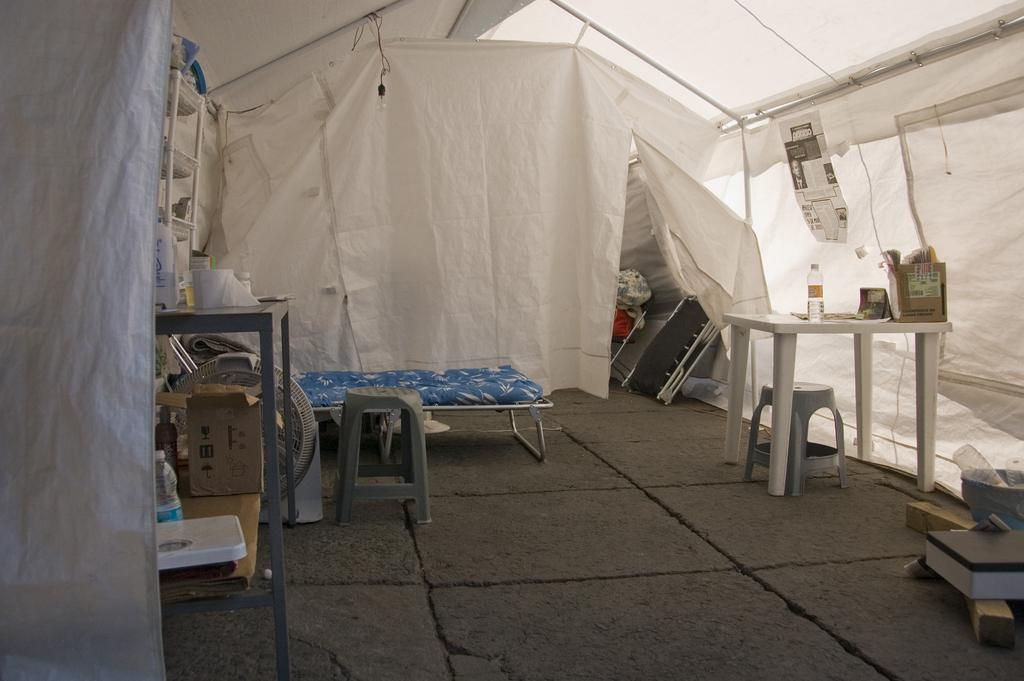What type of furniture is present in the image? There is a stool and a table in the image. What items can be seen on the table? There are bottles and a carton box on the table. What part of the room is visible in the image? The floor is visible in the image. What other piece of furniture is in the room? There is a bed in the image. What is the overall setting of the image? It appears to be a tent in the image. What is the chance of finding a feather on the stool in the image? There is no mention of a feather in the image, so it cannot be determined if there is a chance of finding one on the stool. How many cats are visible in the image? There are no cats present in the image. 